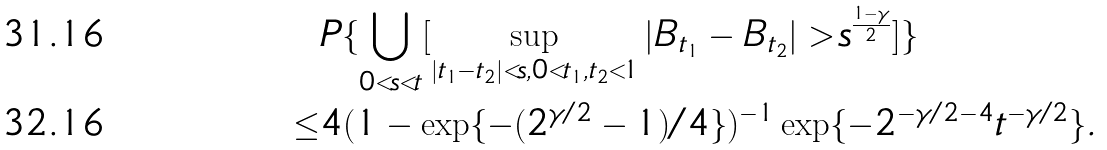Convert formula to latex. <formula><loc_0><loc_0><loc_500><loc_500>& P \{ \bigcup _ { 0 < s < t } [ \sup _ { | t _ { 1 } - t _ { 2 } | < s , 0 < t _ { 1 } , t _ { 2 } < 1 } | B _ { t _ { 1 } } - B _ { t _ { 2 } } | > s ^ { \frac { 1 - \gamma } { 2 } } ] \} \\ \leq & 4 ( 1 - \exp \{ { - ( 2 ^ { \gamma / 2 } - 1 ) / 4 } \} ) ^ { - 1 } \exp \{ - 2 ^ { - \gamma / 2 - 4 } t ^ { - \gamma / 2 } \} .</formula> 